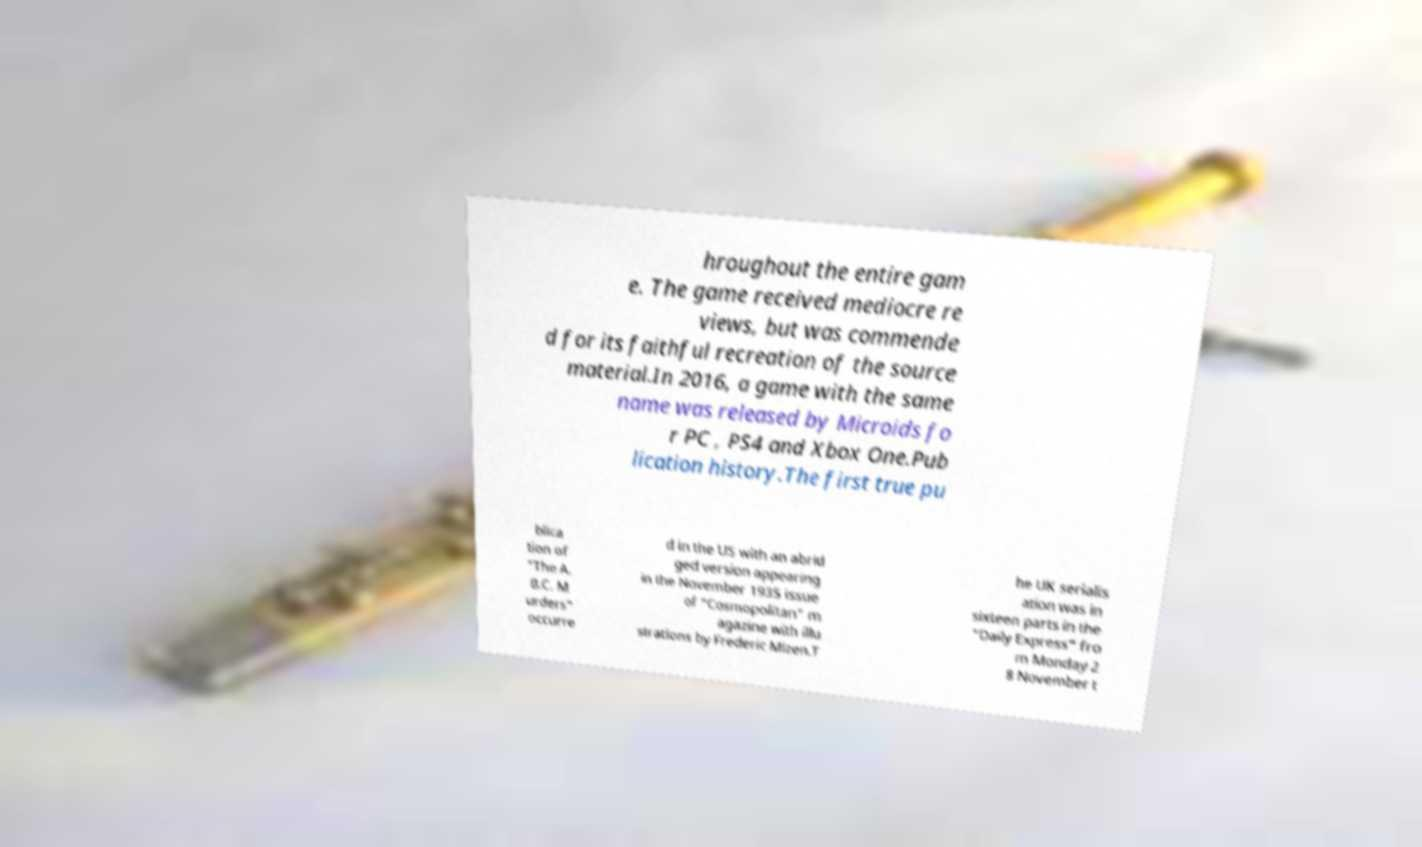Please read and relay the text visible in this image. What does it say? hroughout the entire gam e. The game received mediocre re views, but was commende d for its faithful recreation of the source material.In 2016, a game with the same name was released by Microids fo r PC , PS4 and Xbox One.Pub lication history.The first true pu blica tion of "The A. B.C. M urders" occurre d in the US with an abrid ged version appearing in the November 1935 issue of "Cosmopolitan" m agazine with illu strations by Frederic Mizen.T he UK serialis ation was in sixteen parts in the "Daily Express" fro m Monday 2 8 November t 